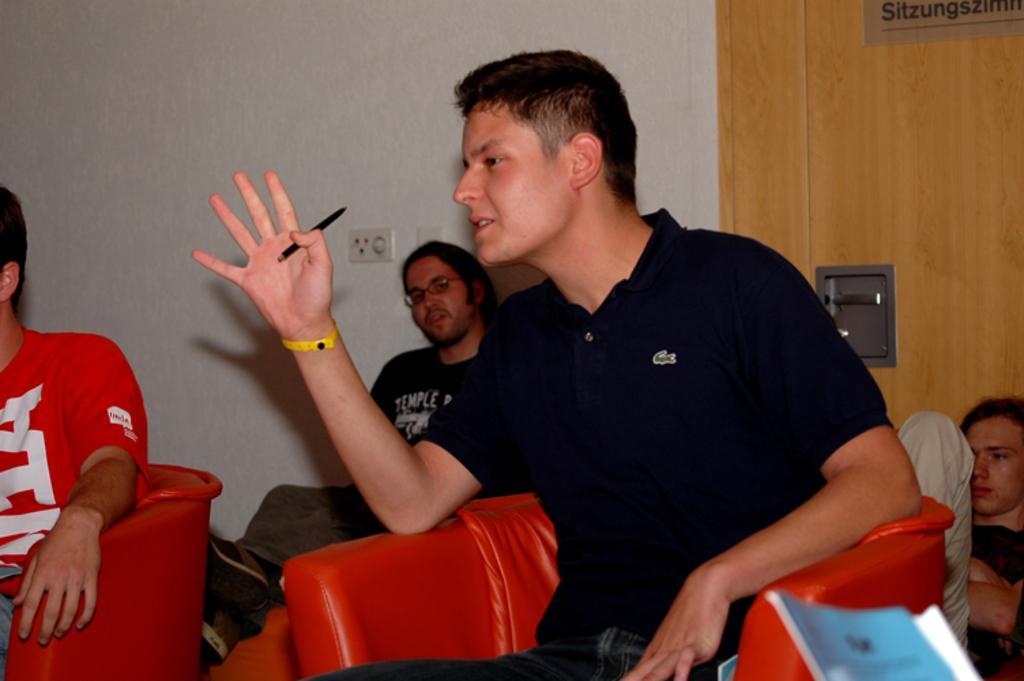In one or two sentences, can you explain what this image depicts? In the image we can see there are people sitting on the chair and a man is holding pen in his hand. Behind there is a door and there is a white colour wall. There is a socket on the wall. 